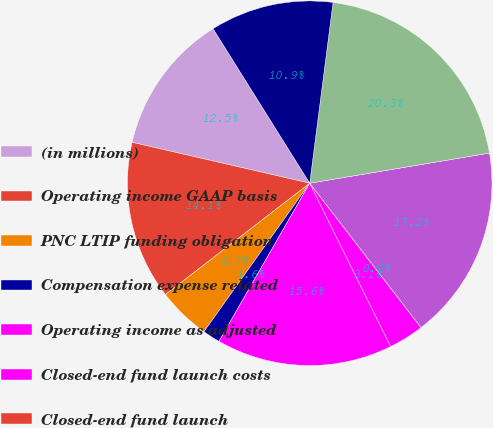Convert chart. <chart><loc_0><loc_0><loc_500><loc_500><pie_chart><fcel>(in millions)<fcel>Operating income GAAP basis<fcel>PNC LTIP funding obligation<fcel>Compensation expense related<fcel>Operating income as adjusted<fcel>Closed-end fund launch costs<fcel>Closed-end fund launch<fcel>Operating income used for<fcel>Revenue GAAP basis<fcel>Distribution and servicing<nl><fcel>12.5%<fcel>14.06%<fcel>4.69%<fcel>1.56%<fcel>15.62%<fcel>3.13%<fcel>0.0%<fcel>17.19%<fcel>20.31%<fcel>10.94%<nl></chart> 